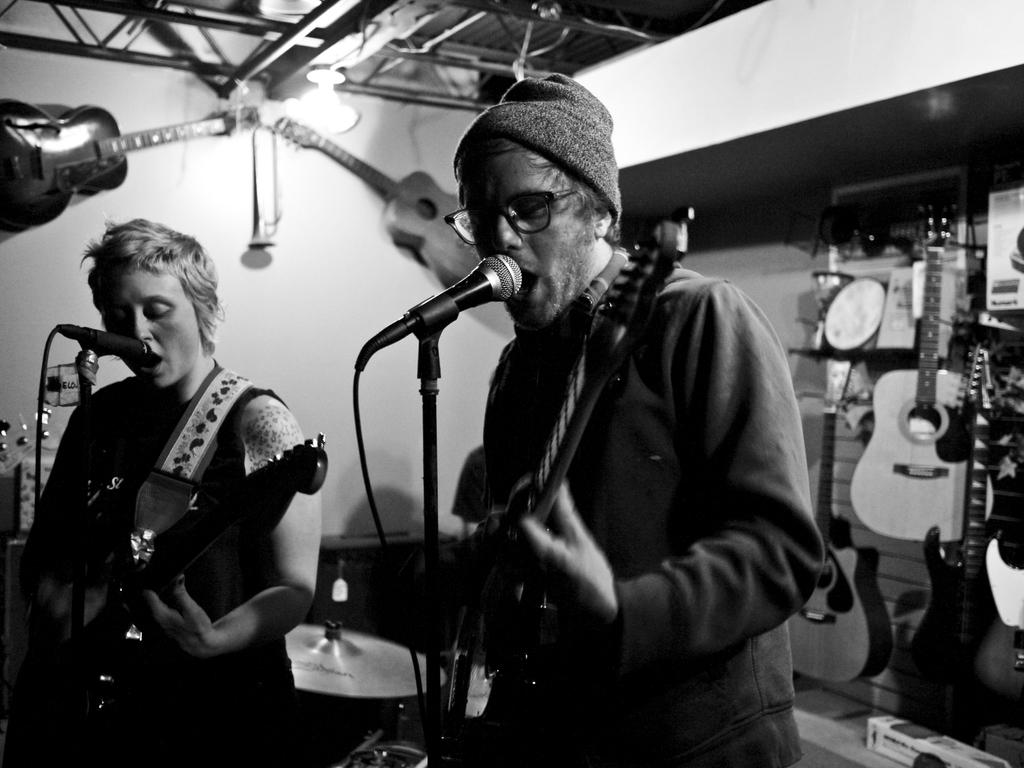How many people are in the image? There are two persons in the image. What are the two persons doing in the image? The two persons are holding guitars and playing them. How are the two persons communicating their voices in the image? The two persons are singing through microphones. What can be seen in the background of the image? There are many guitars visible in the background of the image. What type of butter is being used to tune the guitars in the image? There is no butter present in the image, and guitars are not tuned using butter. 